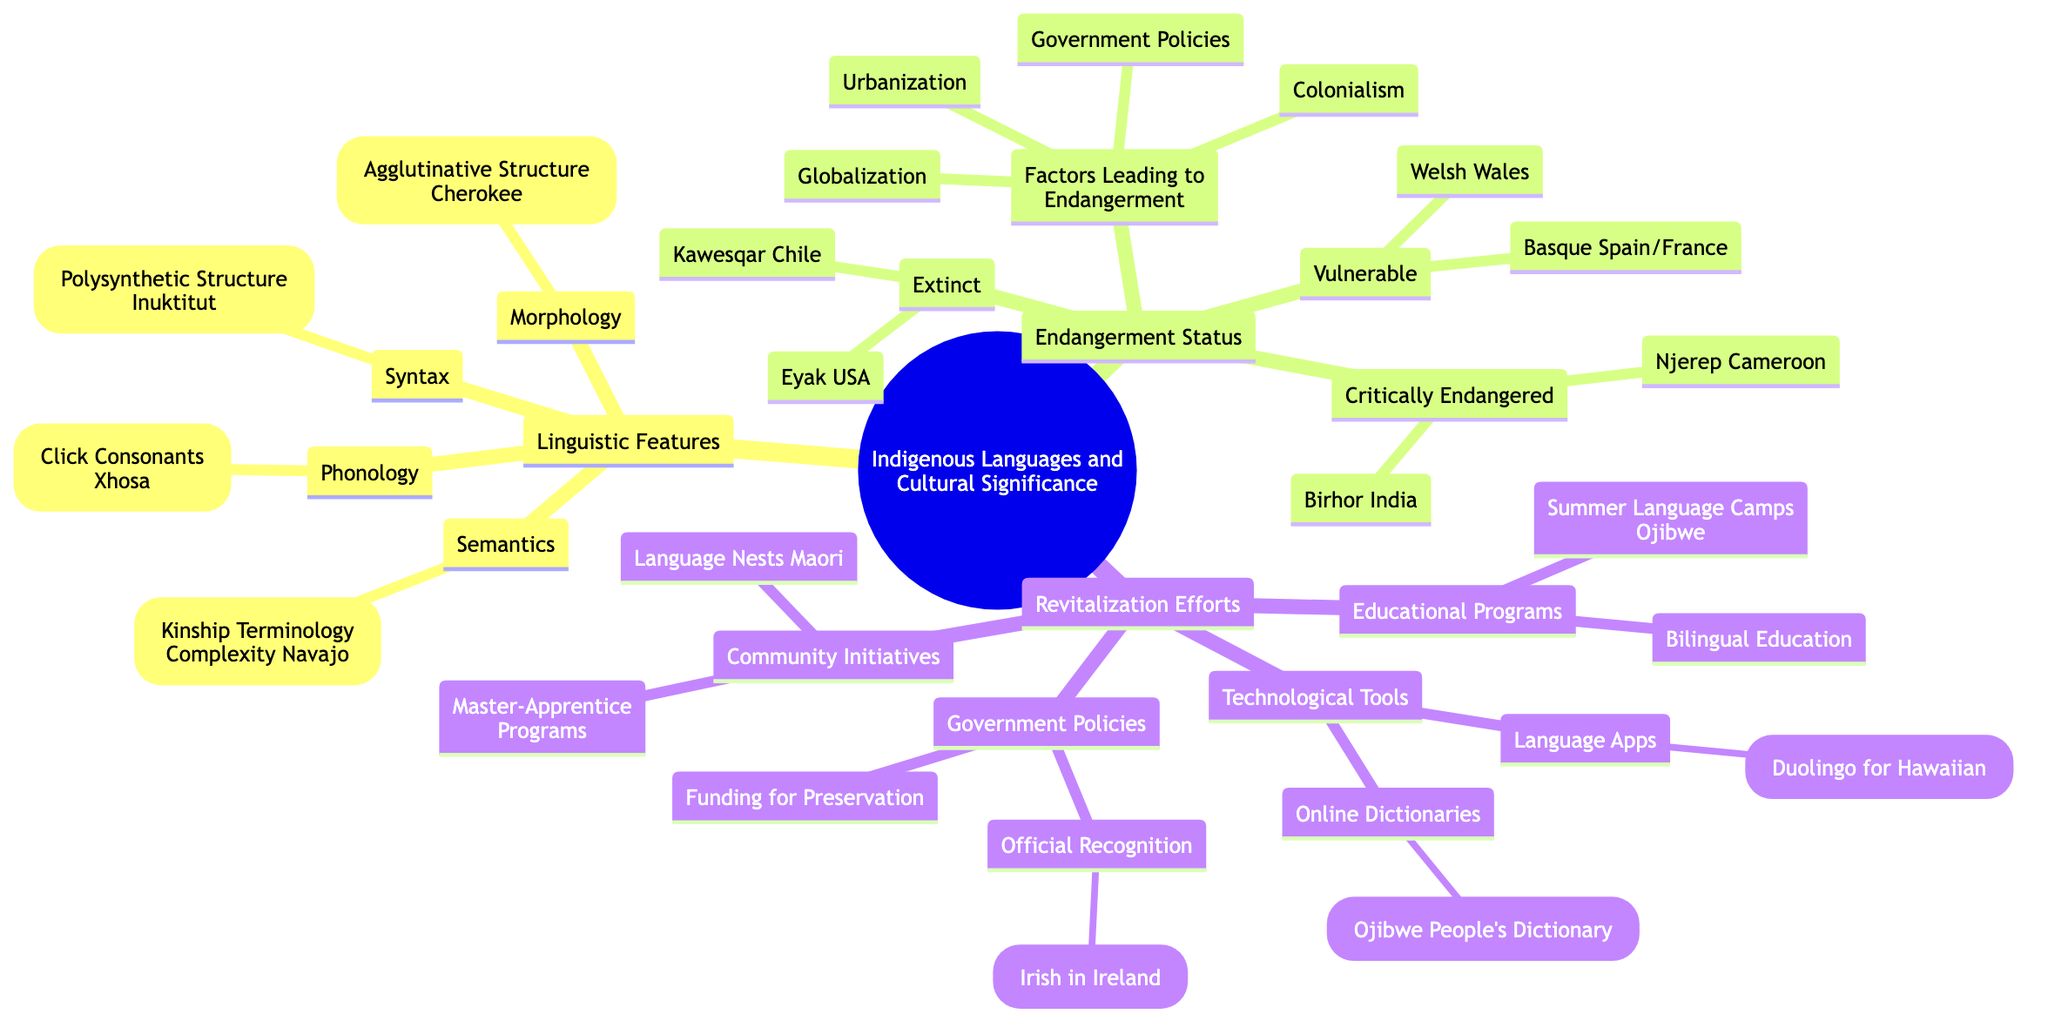What are the four linguistic features mentioned? The diagram lists four linguistic features under the "Linguistic Features" node: Syntax, Phonology, Morphology, and Semantics. This information is directly visible in the structure of the mind map, where these categories are connected to the main topic.
Answer: Syntax, Phonology, Morphology, Semantics Which language is associated with Click Consonants? The mind map indicates that Click Consonants are specifically related to the Xhosa language. This is found in the "Phonology" subtopic, where languages are paired with their corresponding linguistic features.
Answer: Xhosa How many languages are listed as critically endangered? There are two languages listed under the "Critically Endangered" status: Birhor and Njerep. This can be calculated by counting the items under that particular subtopic.
Answer: 2 What is one factor that leads to the endangerment of languages? The mind map provides several factors that lead to language endangerment, one of which is Colonialism. This information is grouped together under the "Factors Leading to Endangerment" category, indicating the root causes of language decline.
Answer: Colonialism What revitalization effort is associated with the Maori culture? The diagram mentions "Language Nests" under the community initiatives for revitalization efforts. It shows specific strategies to preserve indigenous languages, linking them to cultural contexts effectively.
Answer: Language Nests How many language apps are mentioned in the technological tools? The mind map states that one language app, specifically Duolingo for Hawaiian, is mentioned under the "Technological Tools." This implies a focus on using technology for language learning and preservation, stated directly within that category.
Answer: 1 Which language is extinct according to the diagram? The diagram states that Eyak is an extinct language listed under the "Extinct" category. This can be identified by looking for language names under that specific subtopic, confirming their current status.
Answer: Eyak What educational program is specifically mentioned for the Ojibwe language? The mind map identifies "Summer Language Camps" under "Educational Programs" related to the Ojibwe language. This highlights targeted efforts to promote language use among the younger generation and can be found in the respective subtopic.
Answer: Summer Language Camps What type of recognition is an example of a government policy? Official Recognition of Irish in Ireland is an example of a government policy aimed at language preservation and revitalization, as listed under the "Government Policies" section in the mind map. This reflects the involvement of state efforts in supporting indigenous languages.
Answer: Official Recognition 